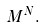Convert formula to latex. <formula><loc_0><loc_0><loc_500><loc_500>M ^ { N } .</formula> 